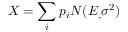<formula> <loc_0><loc_0><loc_500><loc_500>X = \sum _ { i } p _ { i } N ( E _ { , } \sigma ^ { 2 } )</formula> 